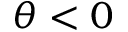Convert formula to latex. <formula><loc_0><loc_0><loc_500><loc_500>\theta < 0</formula> 